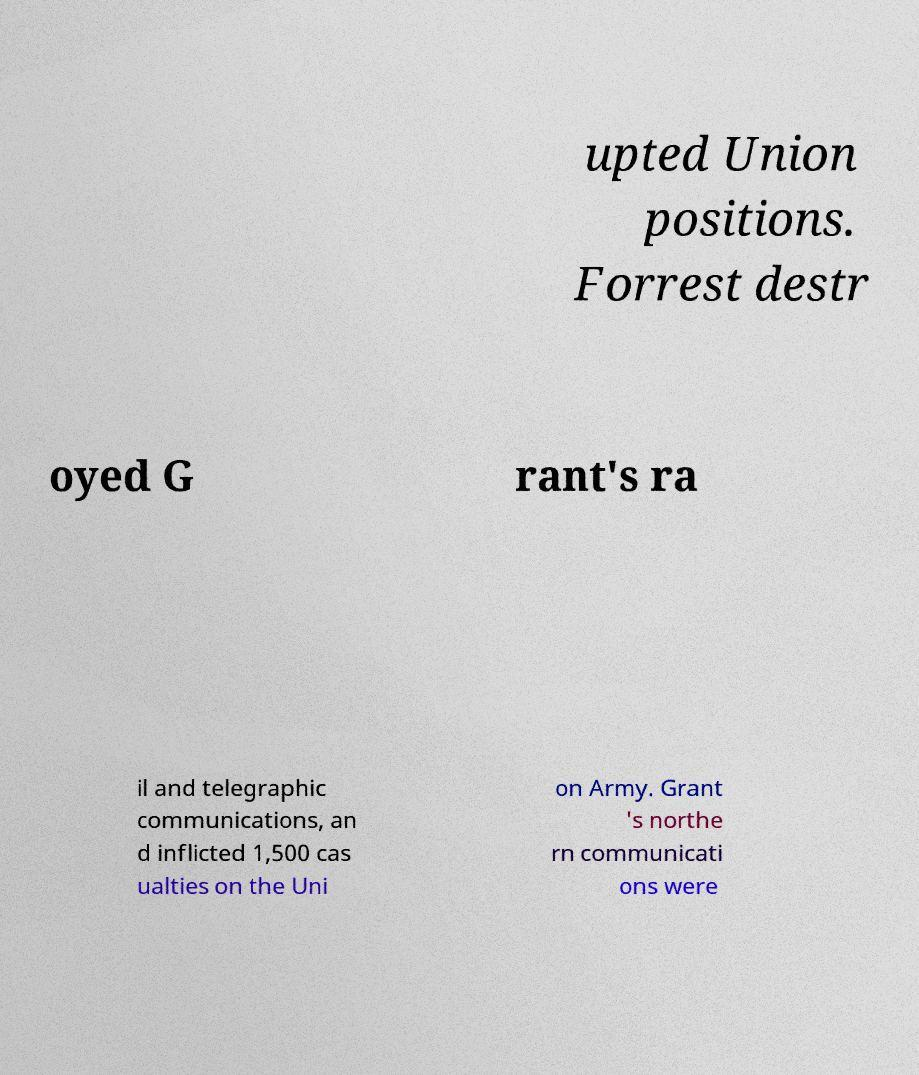Could you extract and type out the text from this image? upted Union positions. Forrest destr oyed G rant's ra il and telegraphic communications, an d inflicted 1,500 cas ualties on the Uni on Army. Grant 's northe rn communicati ons were 